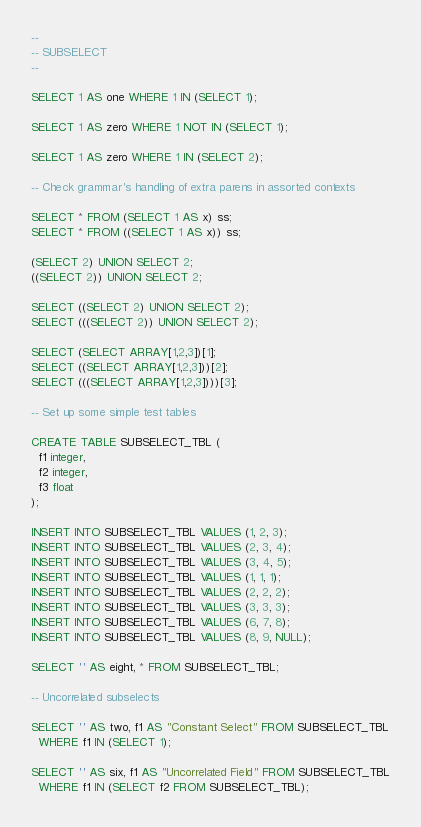<code> <loc_0><loc_0><loc_500><loc_500><_SQL_>--
-- SUBSELECT
--

SELECT 1 AS one WHERE 1 IN (SELECT 1);

SELECT 1 AS zero WHERE 1 NOT IN (SELECT 1);

SELECT 1 AS zero WHERE 1 IN (SELECT 2);

-- Check grammar's handling of extra parens in assorted contexts

SELECT * FROM (SELECT 1 AS x) ss;
SELECT * FROM ((SELECT 1 AS x)) ss;

(SELECT 2) UNION SELECT 2;
((SELECT 2)) UNION SELECT 2;

SELECT ((SELECT 2) UNION SELECT 2);
SELECT (((SELECT 2)) UNION SELECT 2);

SELECT (SELECT ARRAY[1,2,3])[1];
SELECT ((SELECT ARRAY[1,2,3]))[2];
SELECT (((SELECT ARRAY[1,2,3])))[3];

-- Set up some simple test tables

CREATE TABLE SUBSELECT_TBL (
  f1 integer,
  f2 integer,
  f3 float
);

INSERT INTO SUBSELECT_TBL VALUES (1, 2, 3);
INSERT INTO SUBSELECT_TBL VALUES (2, 3, 4);
INSERT INTO SUBSELECT_TBL VALUES (3, 4, 5);
INSERT INTO SUBSELECT_TBL VALUES (1, 1, 1);
INSERT INTO SUBSELECT_TBL VALUES (2, 2, 2);
INSERT INTO SUBSELECT_TBL VALUES (3, 3, 3);
INSERT INTO SUBSELECT_TBL VALUES (6, 7, 8);
INSERT INTO SUBSELECT_TBL VALUES (8, 9, NULL);

SELECT '' AS eight, * FROM SUBSELECT_TBL;

-- Uncorrelated subselects

SELECT '' AS two, f1 AS "Constant Select" FROM SUBSELECT_TBL
  WHERE f1 IN (SELECT 1);

SELECT '' AS six, f1 AS "Uncorrelated Field" FROM SUBSELECT_TBL
  WHERE f1 IN (SELECT f2 FROM SUBSELECT_TBL);
</code> 